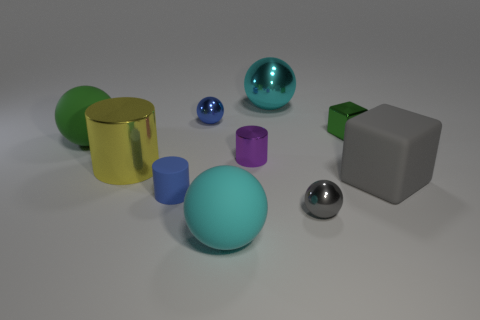Subtract all cyan rubber spheres. How many spheres are left? 4 Subtract all green spheres. How many spheres are left? 4 Subtract all yellow spheres. Subtract all green cylinders. How many spheres are left? 5 Subtract all cylinders. How many objects are left? 7 Add 6 tiny blue matte cylinders. How many tiny blue matte cylinders are left? 7 Add 9 big cyan rubber blocks. How many big cyan rubber blocks exist? 9 Subtract 0 red cubes. How many objects are left? 10 Subtract all blue metal cylinders. Subtract all large rubber cubes. How many objects are left? 9 